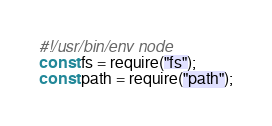<code> <loc_0><loc_0><loc_500><loc_500><_JavaScript_>#!/usr/bin/env node
const fs = require("fs");
const path = require("path");</code> 